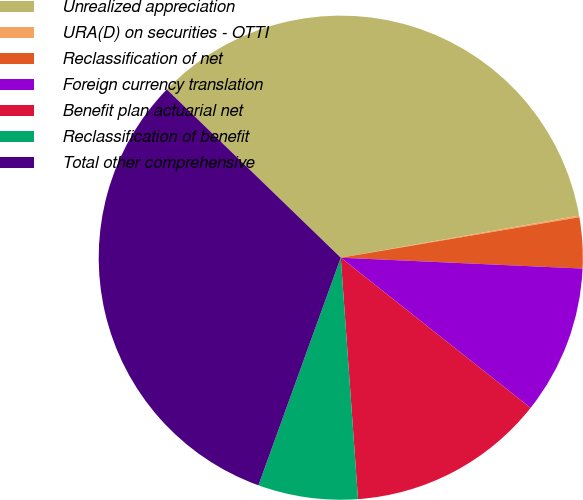Convert chart to OTSL. <chart><loc_0><loc_0><loc_500><loc_500><pie_chart><fcel>Unrealized appreciation<fcel>URA(D) on securities - OTTI<fcel>Reclassification of net<fcel>Foreign currency translation<fcel>Benefit plan actuarial net<fcel>Reclassification of benefit<fcel>Total other comprehensive<nl><fcel>34.98%<fcel>0.11%<fcel>3.39%<fcel>9.94%<fcel>13.21%<fcel>6.66%<fcel>31.71%<nl></chart> 